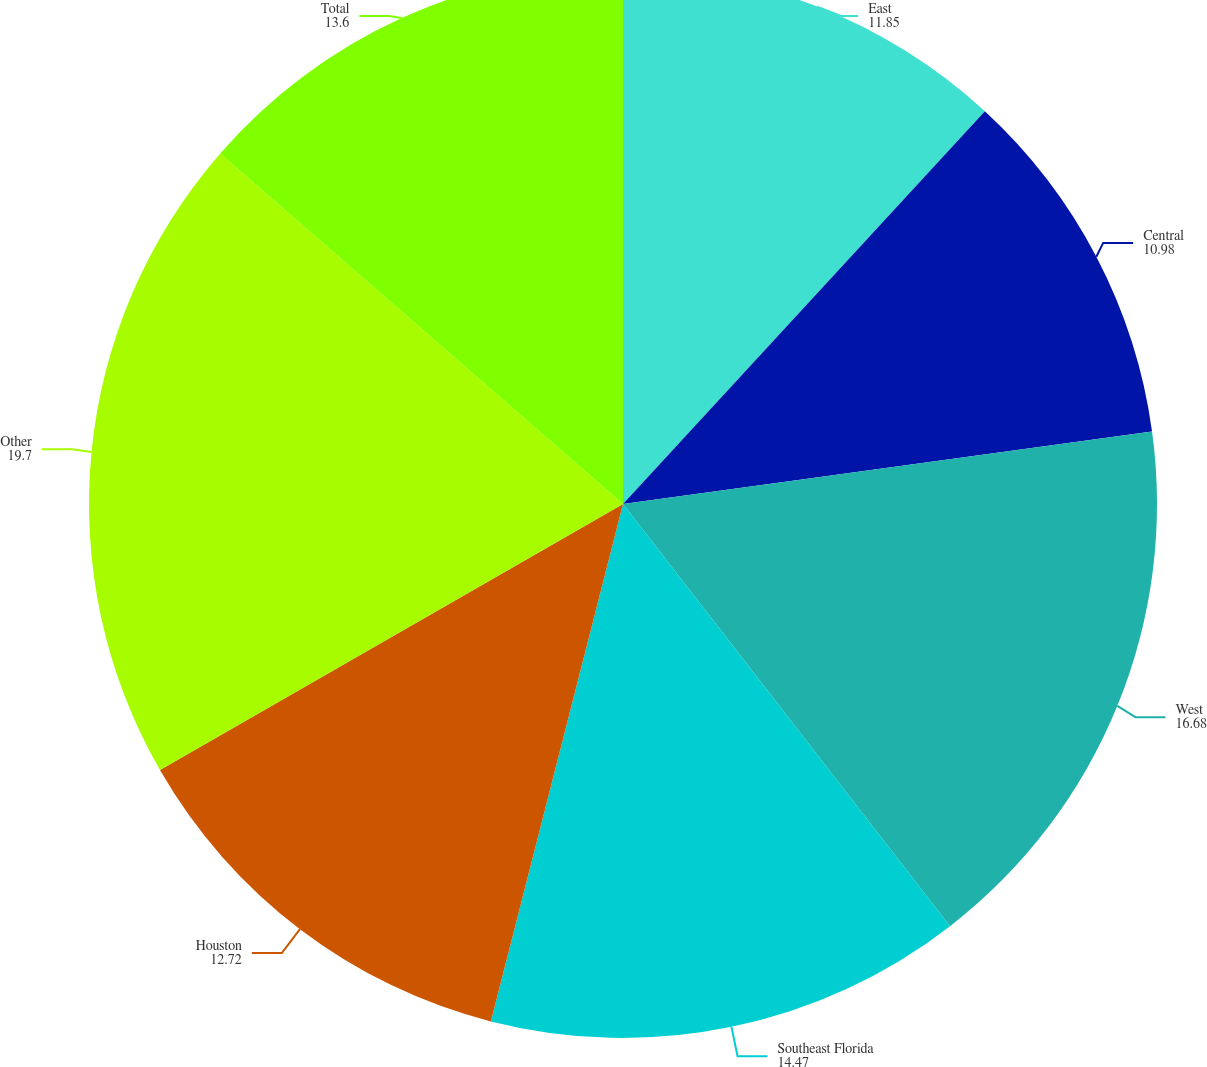Convert chart to OTSL. <chart><loc_0><loc_0><loc_500><loc_500><pie_chart><fcel>East<fcel>Central<fcel>West<fcel>Southeast Florida<fcel>Houston<fcel>Other<fcel>Total<nl><fcel>11.85%<fcel>10.98%<fcel>16.68%<fcel>14.47%<fcel>12.72%<fcel>19.7%<fcel>13.6%<nl></chart> 